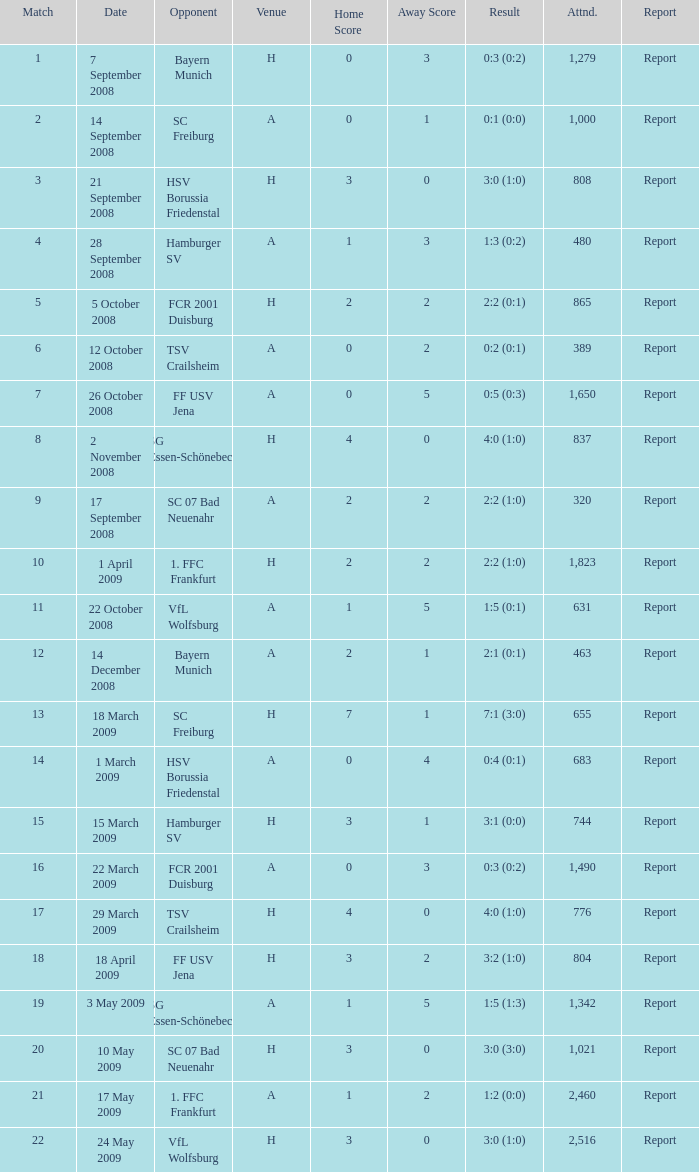What is the match number that had a result of 0:5 (0:3)? 1.0. 